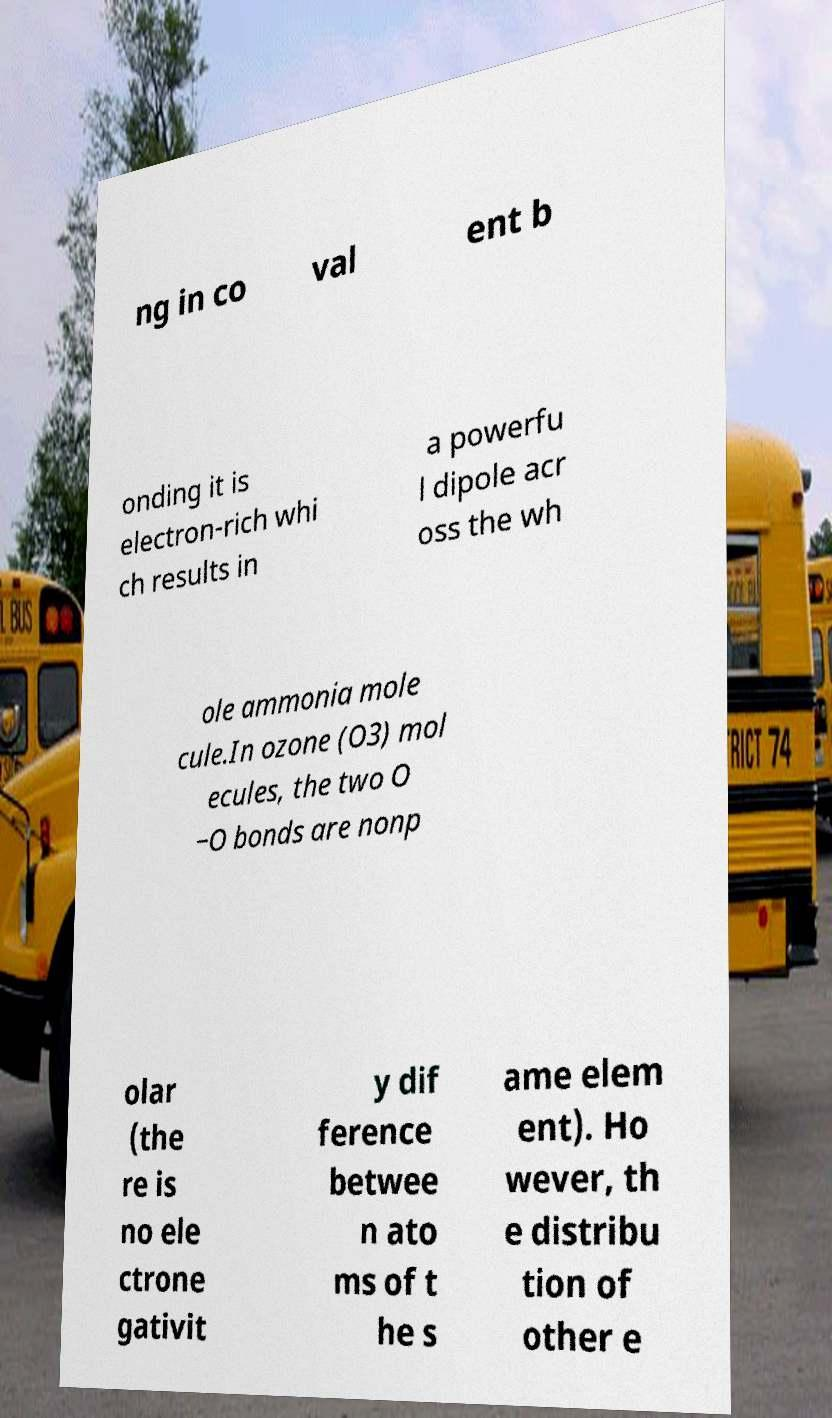Please read and relay the text visible in this image. What does it say? ng in co val ent b onding it is electron-rich whi ch results in a powerfu l dipole acr oss the wh ole ammonia mole cule.In ozone (O3) mol ecules, the two O −O bonds are nonp olar (the re is no ele ctrone gativit y dif ference betwee n ato ms of t he s ame elem ent). Ho wever, th e distribu tion of other e 